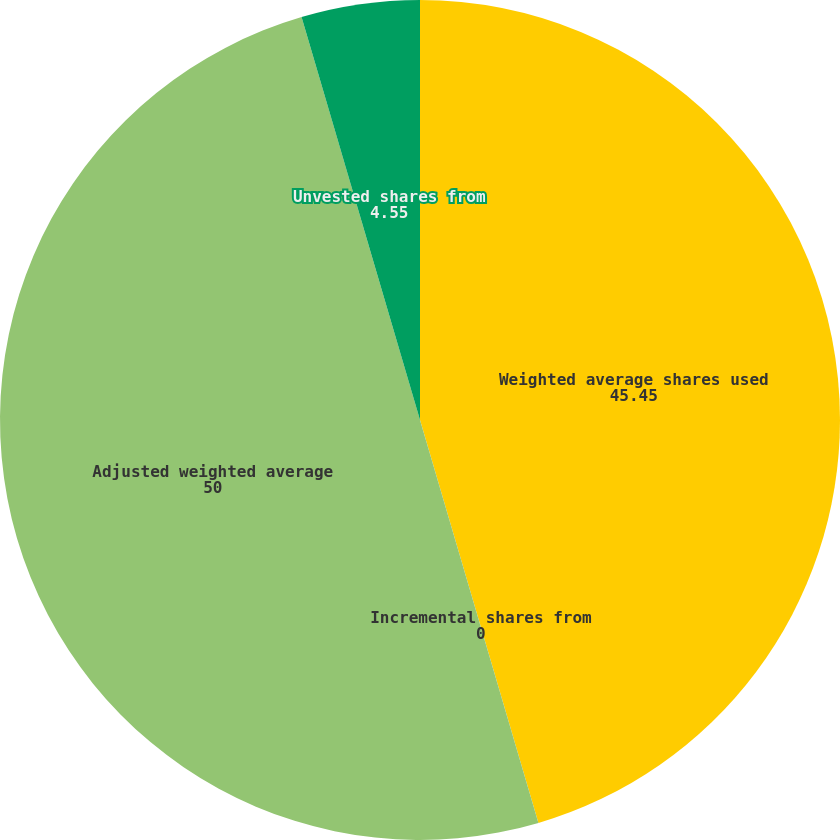Convert chart. <chart><loc_0><loc_0><loc_500><loc_500><pie_chart><fcel>Weighted average shares used<fcel>Incremental shares from<fcel>Adjusted weighted average<fcel>Unvested shares from<nl><fcel>45.45%<fcel>0.0%<fcel>50.0%<fcel>4.55%<nl></chart> 